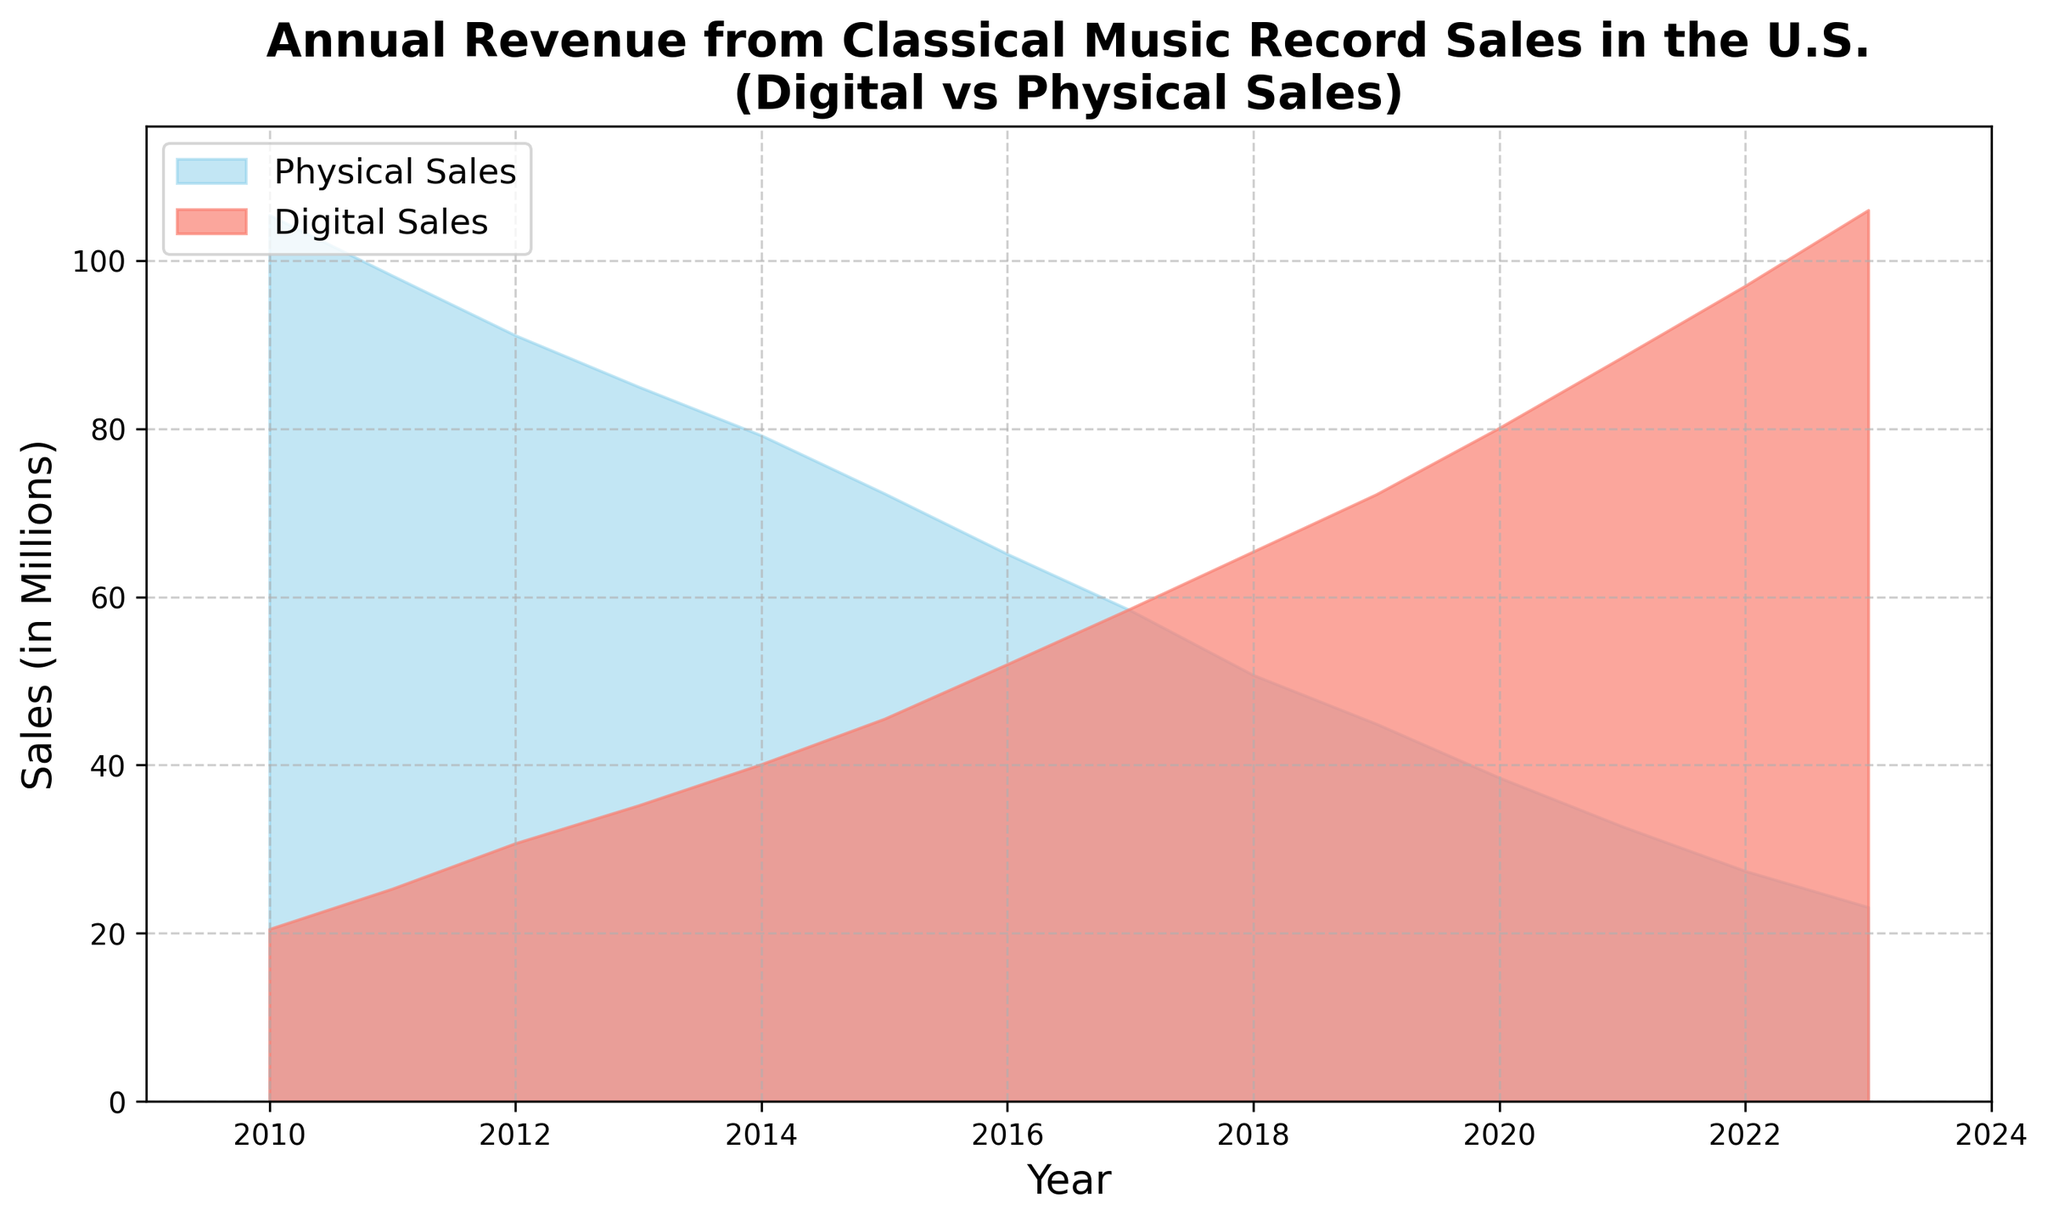Which year had the highest Digital Sales? From the area chart, we can observe that Digital Sales increase year by year. The highest point is at the rightmost side of the chart, which corresponds to the year 2023.
Answer: 2023 How do the Digital Sales and Physical Sales compare in 2017? Looking at the height of the areas in 2017, it is clear that Digital Sales (58.6 million) are slightly higher than Physical Sales (58.4 million) by 0.2 million.
Answer: Digital Sales are higher by 0.2 million In which year did Digital Sales surpass Physical Sales for the first time? To find when Digital Sales first exceed Physical Sales, notice where the red (salmon) area becomes taller than the blue (skyblue) area. This happens in 2017.
Answer: 2017 What was the total sales (Digital + Physical) in 2015? Sum the values for Digital Sales (45.5) and Physical Sales (72.3) in 2015 from the chart. This gives 45.5 + 72.3 = 117.8 million.
Answer: 117.8 million By how much did Physical Sales decrease from 2010 to 2023? From the chart, Physical Sales in 2010 were 105.4 million, and in 2023, they were 23.1 million. The difference is 105.4 - 23.1 = 82.3 million.
Answer: 82.3 million What is the average Digital Sales figure shown in the chart? To get the average, sum all the Digital Sales values provided (20.5 + 25.3 + 30.7 + 35.2 + 40.1 + 45.5 + 52.0 + 58.6 + 65.4 + 72.2 + 80.1 + 88.5 + 97.0 + 106.0 = 817.1) and divide by the number of years (14). This gives 817.1 / 14 = 58.36 million.
Answer: 58.36 million What is the trend in Physical Sales over the years shown? Observing the chart, it is clear that Physical Sales consistently decrease every year from 2010 (105.4 million) to 2023 (23.1 million).
Answer: Consistent decrease In 2022, what is the difference between Digital Sales and Physical Sales? From the chart data, Digital Sales are 97.0 million and Physical Sales are 27.4 million in 2022. The difference is 97.0 - 27.4 = 69.6 million.
Answer: 69.6 million How do the sales numbers in 2023 compare, visually, in terms of area covered by Digital and Physical Sales? Visually, the area under the Digital Sales curve (red) is significantly larger, occupying much more space and extending higher up the y-axis, as compared to the Physical Sales (blue) in 2023.
Answer: Digital Sales area is significantly larger 